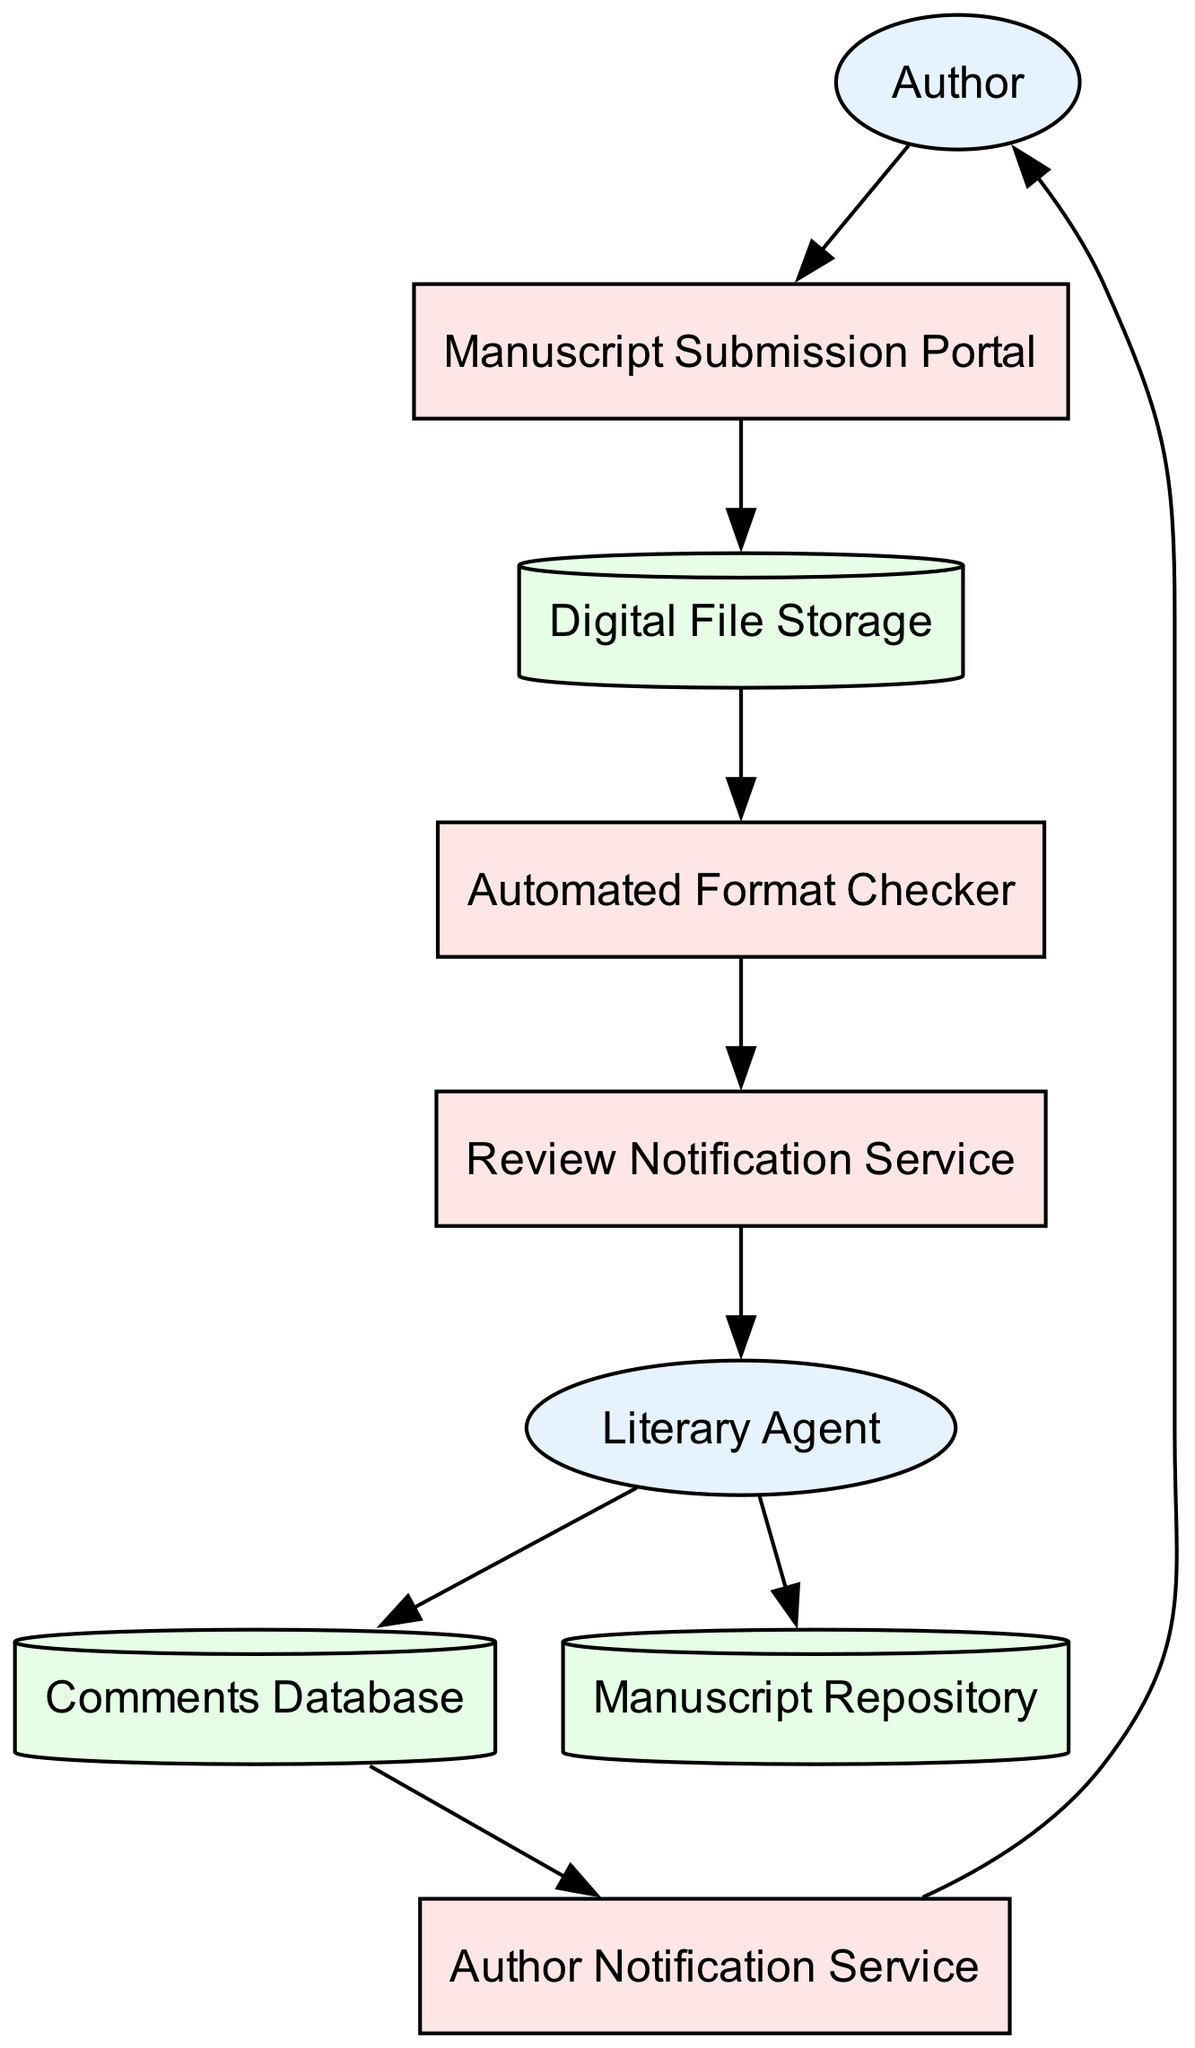What's the first step an author takes in the diagram? The author begins by submitting their manuscript through the "Manuscript Submission Portal".
Answer: Manuscript Submission Portal How many storage components are present in the diagram? There are three storage components: "Digital File Storage", "Comments Database", and "Manuscript Repository".
Answer: Three What service notifies the literary agent? The "Review Notification Service" notifies the literary agent when the manuscripts are ready for review.
Answer: Review Notification Service What is the relationship between "Literary Agent" and "Manuscript Repository"? The literary agent sends approved manuscripts to the "Manuscript Repository".
Answer: Sends approved manuscripts Which entity interacts directly with the "Author Notification Service"? The "Literary Agent" interacts directly with the "Author Notification Service" by providing feedback for authors.
Answer: Literary Agent What process does the manuscript go through after being stored? The manuscript is checked by the "Automated Format Checker" for formatting requirements after being stored.
Answer: Automated Format Checker Which component is responsible for checking the manuscript format? The "Automated Format Checker" is responsible for checking the manuscript format to ensure it meets required standards.
Answer: Automated Format Checker How many entities are depicted in the diagram? There are two entities depicted: "Author" and "Literary Agent".
Answer: Two Which service notifies the author about feedback? The "Author Notification Service" is the service that notifies the author of the feedback received from literary agents.
Answer: Author Notification Service 